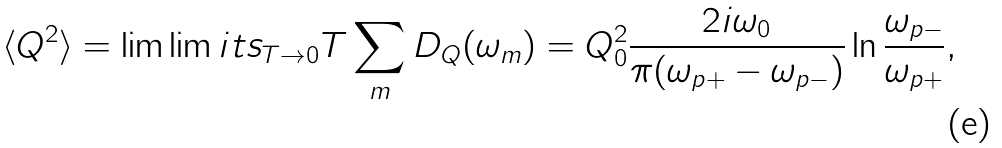<formula> <loc_0><loc_0><loc_500><loc_500>\langle Q ^ { 2 } \rangle = \lim \lim i t s _ { T \rightarrow 0 } T \sum _ { m } D _ { Q } ( \omega _ { m } ) = Q _ { 0 } ^ { 2 } \frac { 2 i \omega _ { 0 } } { \pi ( \omega _ { p + } - \omega _ { p - } ) } \ln \frac { \omega _ { p - } } { \omega _ { p + } } ,</formula> 